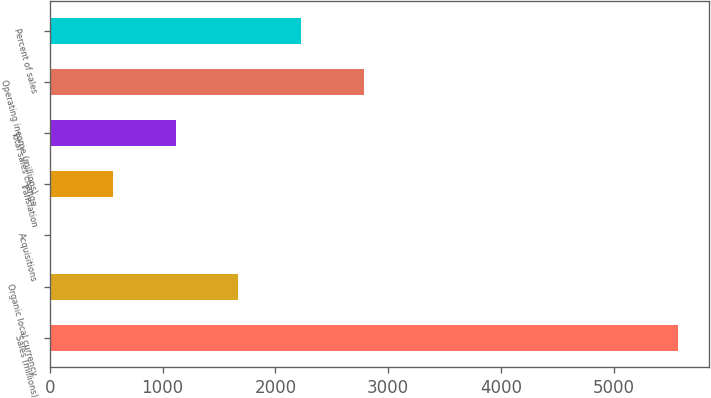Convert chart to OTSL. <chart><loc_0><loc_0><loc_500><loc_500><bar_chart><fcel>Sales (millions)<fcel>Organic local currency<fcel>Acquisitions<fcel>Translation<fcel>Total sales change<fcel>Operating income (millions)<fcel>Percent of sales<nl><fcel>5572<fcel>1671.88<fcel>0.4<fcel>557.56<fcel>1114.72<fcel>2786.2<fcel>2229.04<nl></chart> 